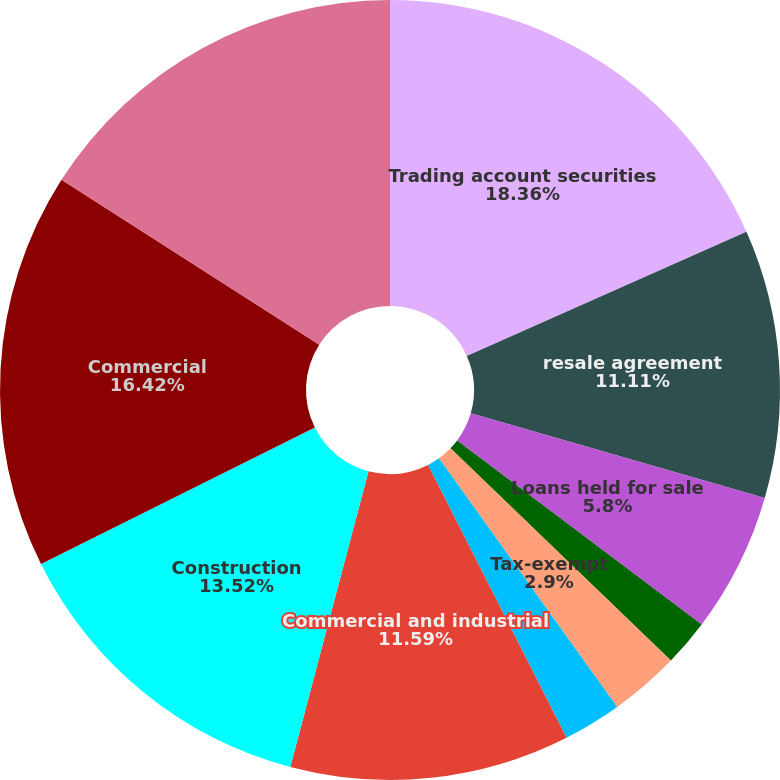Convert chart. <chart><loc_0><loc_0><loc_500><loc_500><pie_chart><fcel>Trading account securities<fcel>resale agreement<fcel>Loans held for sale<fcel>Taxable<fcel>Tax-exempt<fcel>Total investment securities<fcel>Commercial and industrial<fcel>Construction<fcel>Commercial<fcel>Commercial real estate<nl><fcel>18.35%<fcel>11.11%<fcel>5.8%<fcel>1.94%<fcel>2.9%<fcel>2.42%<fcel>11.59%<fcel>13.52%<fcel>16.42%<fcel>15.94%<nl></chart> 